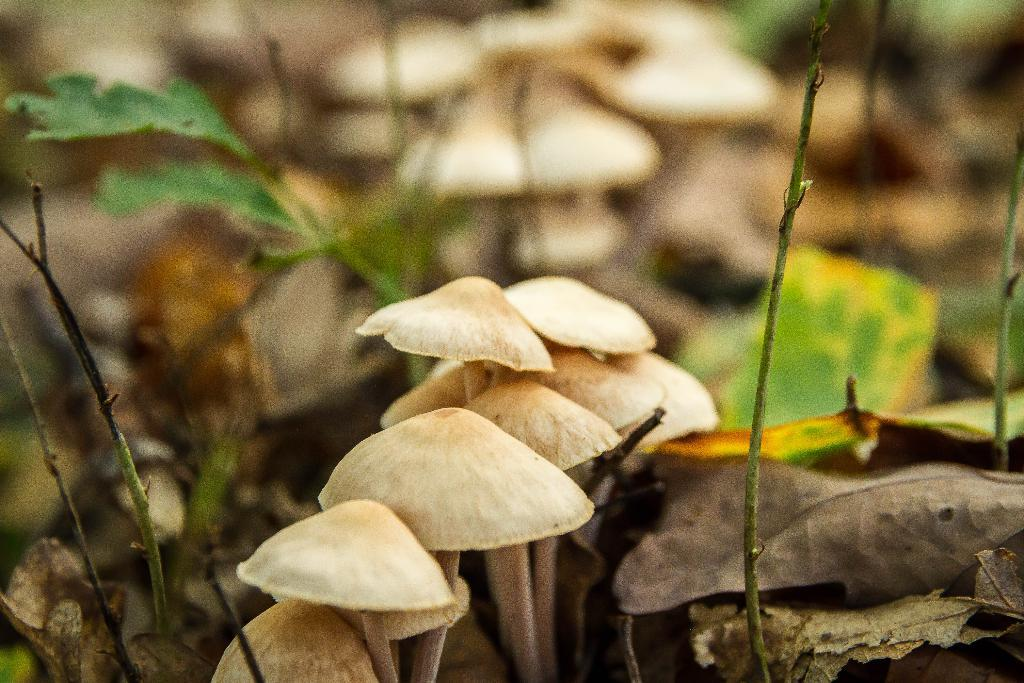What type of fungi can be seen in the image? There are mushrooms in the image. What can be found around the mushrooms? Dry leaves are present around the mushrooms. How is the background of the mushrooms depicted? The background of the mushrooms is blurred. How many hands are visible in the image? There are no hands visible in the image; it features mushrooms and dry leaves. 